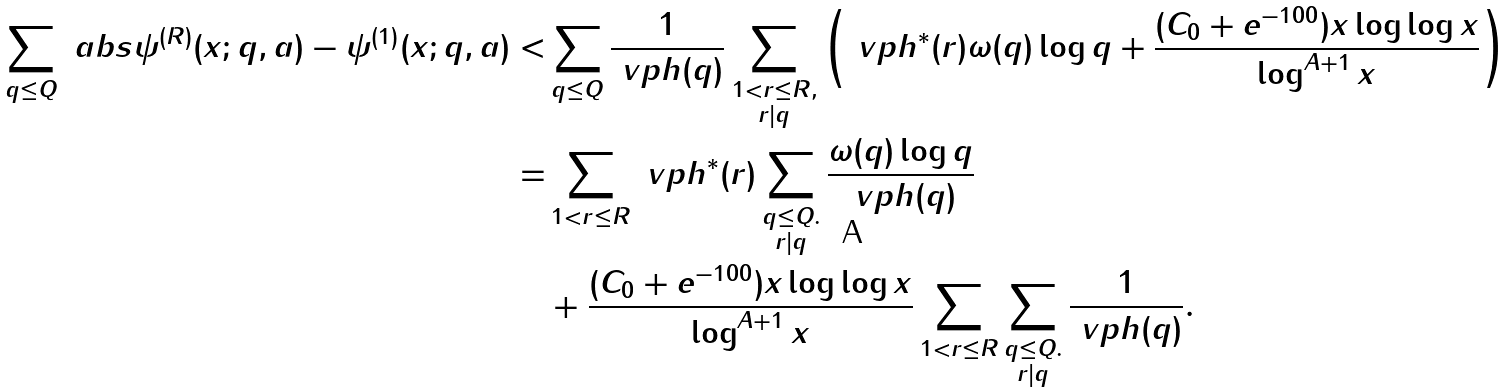<formula> <loc_0><loc_0><loc_500><loc_500>\sum _ { q \leq Q } \ a b s { \psi ^ { ( R ) } ( x ; q , a ) - \psi ^ { ( 1 ) } ( x ; q , a ) } < & \sum _ { q \leq Q } \frac { 1 } { \ v p h ( q ) } \sum _ { \substack { 1 < r \leq R , \\ r | q } } \left ( \ v p h ^ { * } ( r ) \omega ( q ) \log q + \frac { ( C _ { 0 } + e ^ { - 1 0 0 } ) x \log \log x } { \log ^ { A + 1 } x } \right ) \\ = & \sum _ { 1 < r \leq R } \ v p h ^ { * } ( r ) \sum _ { \substack { q \leq Q . \\ r | q } } \frac { \omega ( q ) \log q } { \ v p h ( q ) } \\ & + \frac { ( C _ { 0 } + e ^ { - 1 0 0 } ) x \log \log x } { \log ^ { A + 1 } x } \sum _ { 1 < r \leq R } \sum _ { \substack { q \leq Q . \\ r | q } } \frac { 1 } { \ v p h ( q ) } .</formula> 